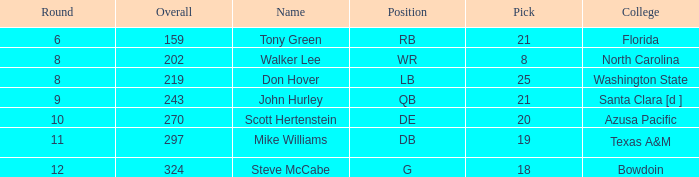How many overalls have a pick greater than 19, with florida as the college? 159.0. 